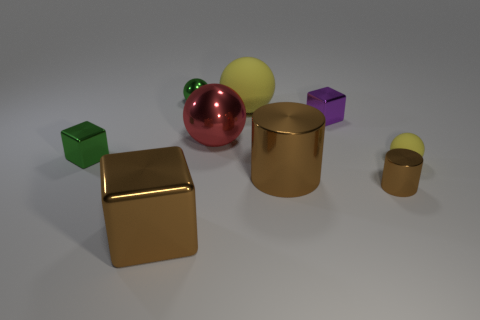How many balls are small yellow things or matte things?
Provide a short and direct response. 2. There is a small green metal thing in front of the big matte sphere; what number of tiny brown cylinders are on the right side of it?
Make the answer very short. 1. Does the large matte thing have the same shape as the small yellow rubber thing?
Your answer should be very brief. Yes. What size is the green shiny object that is the same shape as the tiny purple object?
Make the answer very short. Small. What is the shape of the big red object left of the rubber ball left of the small matte sphere?
Provide a succinct answer. Sphere. How big is the purple metallic thing?
Ensure brevity in your answer.  Small. What is the shape of the tiny rubber thing?
Provide a succinct answer. Sphere. There is a big red shiny thing; is its shape the same as the green thing that is left of the brown block?
Give a very brief answer. No. There is a green thing in front of the red thing; does it have the same shape as the tiny rubber thing?
Your answer should be very brief. No. What number of shiny cubes are both behind the big block and left of the large yellow matte thing?
Give a very brief answer. 1. 